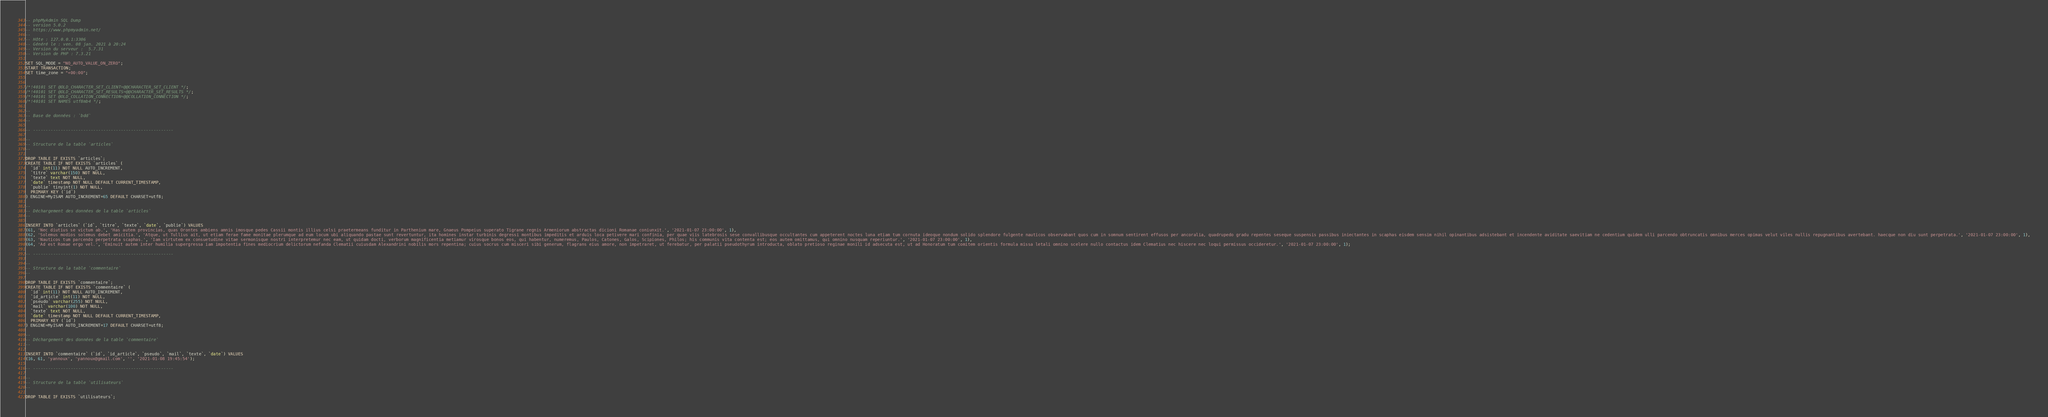Convert code to text. <code><loc_0><loc_0><loc_500><loc_500><_SQL_>-- phpMyAdmin SQL Dump
-- version 5.0.2
-- https://www.phpmyadmin.net/
--
-- Hôte : 127.0.0.1:3306
-- Généré le : ven. 08 jan. 2021 à 20:24
-- Version du serveur :  5.7.31
-- Version de PHP : 7.3.21

SET SQL_MODE = "NO_AUTO_VALUE_ON_ZERO";
START TRANSACTION;
SET time_zone = "+00:00";


/*!40101 SET @OLD_CHARACTER_SET_CLIENT=@@CHARACTER_SET_CLIENT */;
/*!40101 SET @OLD_CHARACTER_SET_RESULTS=@@CHARACTER_SET_RESULTS */;
/*!40101 SET @OLD_COLLATION_CONNECTION=@@COLLATION_CONNECTION */;
/*!40101 SET NAMES utf8mb4 */;

--
-- Base de données : `bdd`
--

-- --------------------------------------------------------

--
-- Structure de la table `articles`
--

DROP TABLE IF EXISTS `articles`;
CREATE TABLE IF NOT EXISTS `articles` (
  `id` int(11) NOT NULL AUTO_INCREMENT,
  `titre` varchar(150) NOT NULL,
  `texte` text NOT NULL,
  `date` timestamp NOT NULL DEFAULT CURRENT_TIMESTAMP,
  `publie` tinyint(1) NOT NULL,
  PRIMARY KEY (`id`)
) ENGINE=MyISAM AUTO_INCREMENT=65 DEFAULT CHARSET=utf8;

--
-- Déchargement des données de la table `articles`
--

INSERT INTO `articles` (`id`, `titre`, `texte`, `date`, `publie`) VALUES
(61, 'Nec diutius se victum ab.', 'Has autem provincias, quas Orontes ambiens amnis imosque pedes Cassii montis illius celsi praetermeans funditur in Parthenium mare, Gnaeus Pompeius superato Tigrane regnis Armeniorum abstractas dicioni Romanae coniunxit.', '2021-01-07 23:00:00', 1),
(62, 'Solemus modios solemus debet amicitia.', 'Atque, ut Tullius ait, ut etiam ferae fame monitae plerumque ad eum locum ubi aliquando pastae sunt revertuntur, ita homines instar turbinis degressi montibus impeditis et arduis loca petivere mari confinia, per quae viis latebrosis sese convallibusque occultantes cum appeterent noctes luna etiam tum cornuta ideoque nondum solido splendore fulgente nauticos observabant quos cum in somnum sentirent effusos per ancoralia, quadrupedo gradu repentes seseque suspensis passibus iniectantes in scaphas eisdem sensim nihil opinantibus adsistebant et incendente aviditate saevitiam ne cedentium quidem ulli parcendo obtruncatis omnibus merces opimas velut viles nullis repugnantibus avertebant. haecque non diu sunt perpetrata.', '2021-01-07 23:00:00', 1),
(63, 'Nauticos tum parcendo perpetrata scaphas.', 'Iam virtutem ex consuetudine vitae sermonisque nostri interpretemur nec eam, ut quidam docti, verborum magnificentia metiamur virosque bonos eos, qui habentur, numeremus, Paulos, Catones, Galos, Scipiones, Philos; his communis vita contenta est; eos autem omittamus, qui omnino nusquam reperiuntur.', '2021-01-07 23:00:00', 1),
(64, 'Ad est Romae ergo vel.', 'Eminuit autem inter humilia supergressa iam impotentia fines mediocrium delictorum nefanda Clematii cuiusdam Alexandrini nobilis mors repentina; cuius socrus cum misceri sibi generum, flagrans eius amore, non impetraret, ut ferebatur, per palatii pseudothyrum introducta, oblato pretioso reginae monili id adsecuta est, ut ad Honoratum tum comitem orientis formula missa letali omnino scelere nullo contactus idem Clematius nec hiscere nec loqui permissus occideretur.', '2021-01-07 23:00:00', 1);

-- --------------------------------------------------------

--
-- Structure de la table `commentaire`
--

DROP TABLE IF EXISTS `commentaire`;
CREATE TABLE IF NOT EXISTS `commentaire` (
  `id` int(11) NOT NULL AUTO_INCREMENT,
  `id_article` int(11) NOT NULL,
  `pseudo` varchar(255) NOT NULL,
  `mail` varchar(100) NOT NULL,
  `texte` text NOT NULL,
  `date` timestamp NOT NULL DEFAULT CURRENT_TIMESTAMP,
  PRIMARY KEY (`id`)
) ENGINE=MyISAM AUTO_INCREMENT=17 DEFAULT CHARSET=utf8;

--
-- Déchargement des données de la table `commentaire`
--

INSERT INTO `commentaire` (`id`, `id_article`, `pseudo`, `mail`, `texte`, `date`) VALUES
(16, 61, 'yannoux', 'yannoux@gmail.com', '', '2021-01-08 19:45:54');

-- --------------------------------------------------------

--
-- Structure de la table `utilisateurs`
--

DROP TABLE IF EXISTS `utilisateurs`;</code> 